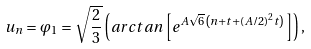<formula> <loc_0><loc_0><loc_500><loc_500>u _ { n } = \varphi _ { 1 } = \sqrt { \frac { 2 } { 3 } } \left ( a r c t a n \left [ e ^ { A \sqrt { 6 } \left ( n + t + ( A / 2 ) ^ { 2 } t \right ) } \right ] \right ) ,</formula> 